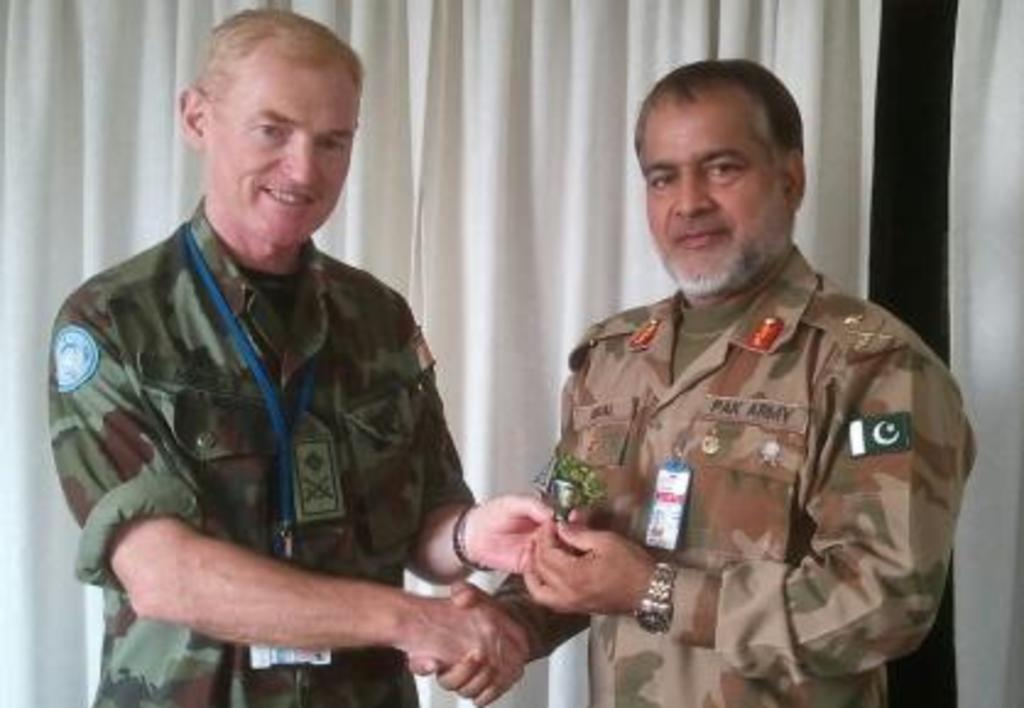How many cops are present in the image? There are two cops in the image. Where are the cops located in the image? The cops are in the center of the image. What can be seen in the background of the image? There is a white color curtain in the background of the image. What type of rail can be seen in the image? There is no rail present in the image; it features two cops and a white color curtain in the background. 